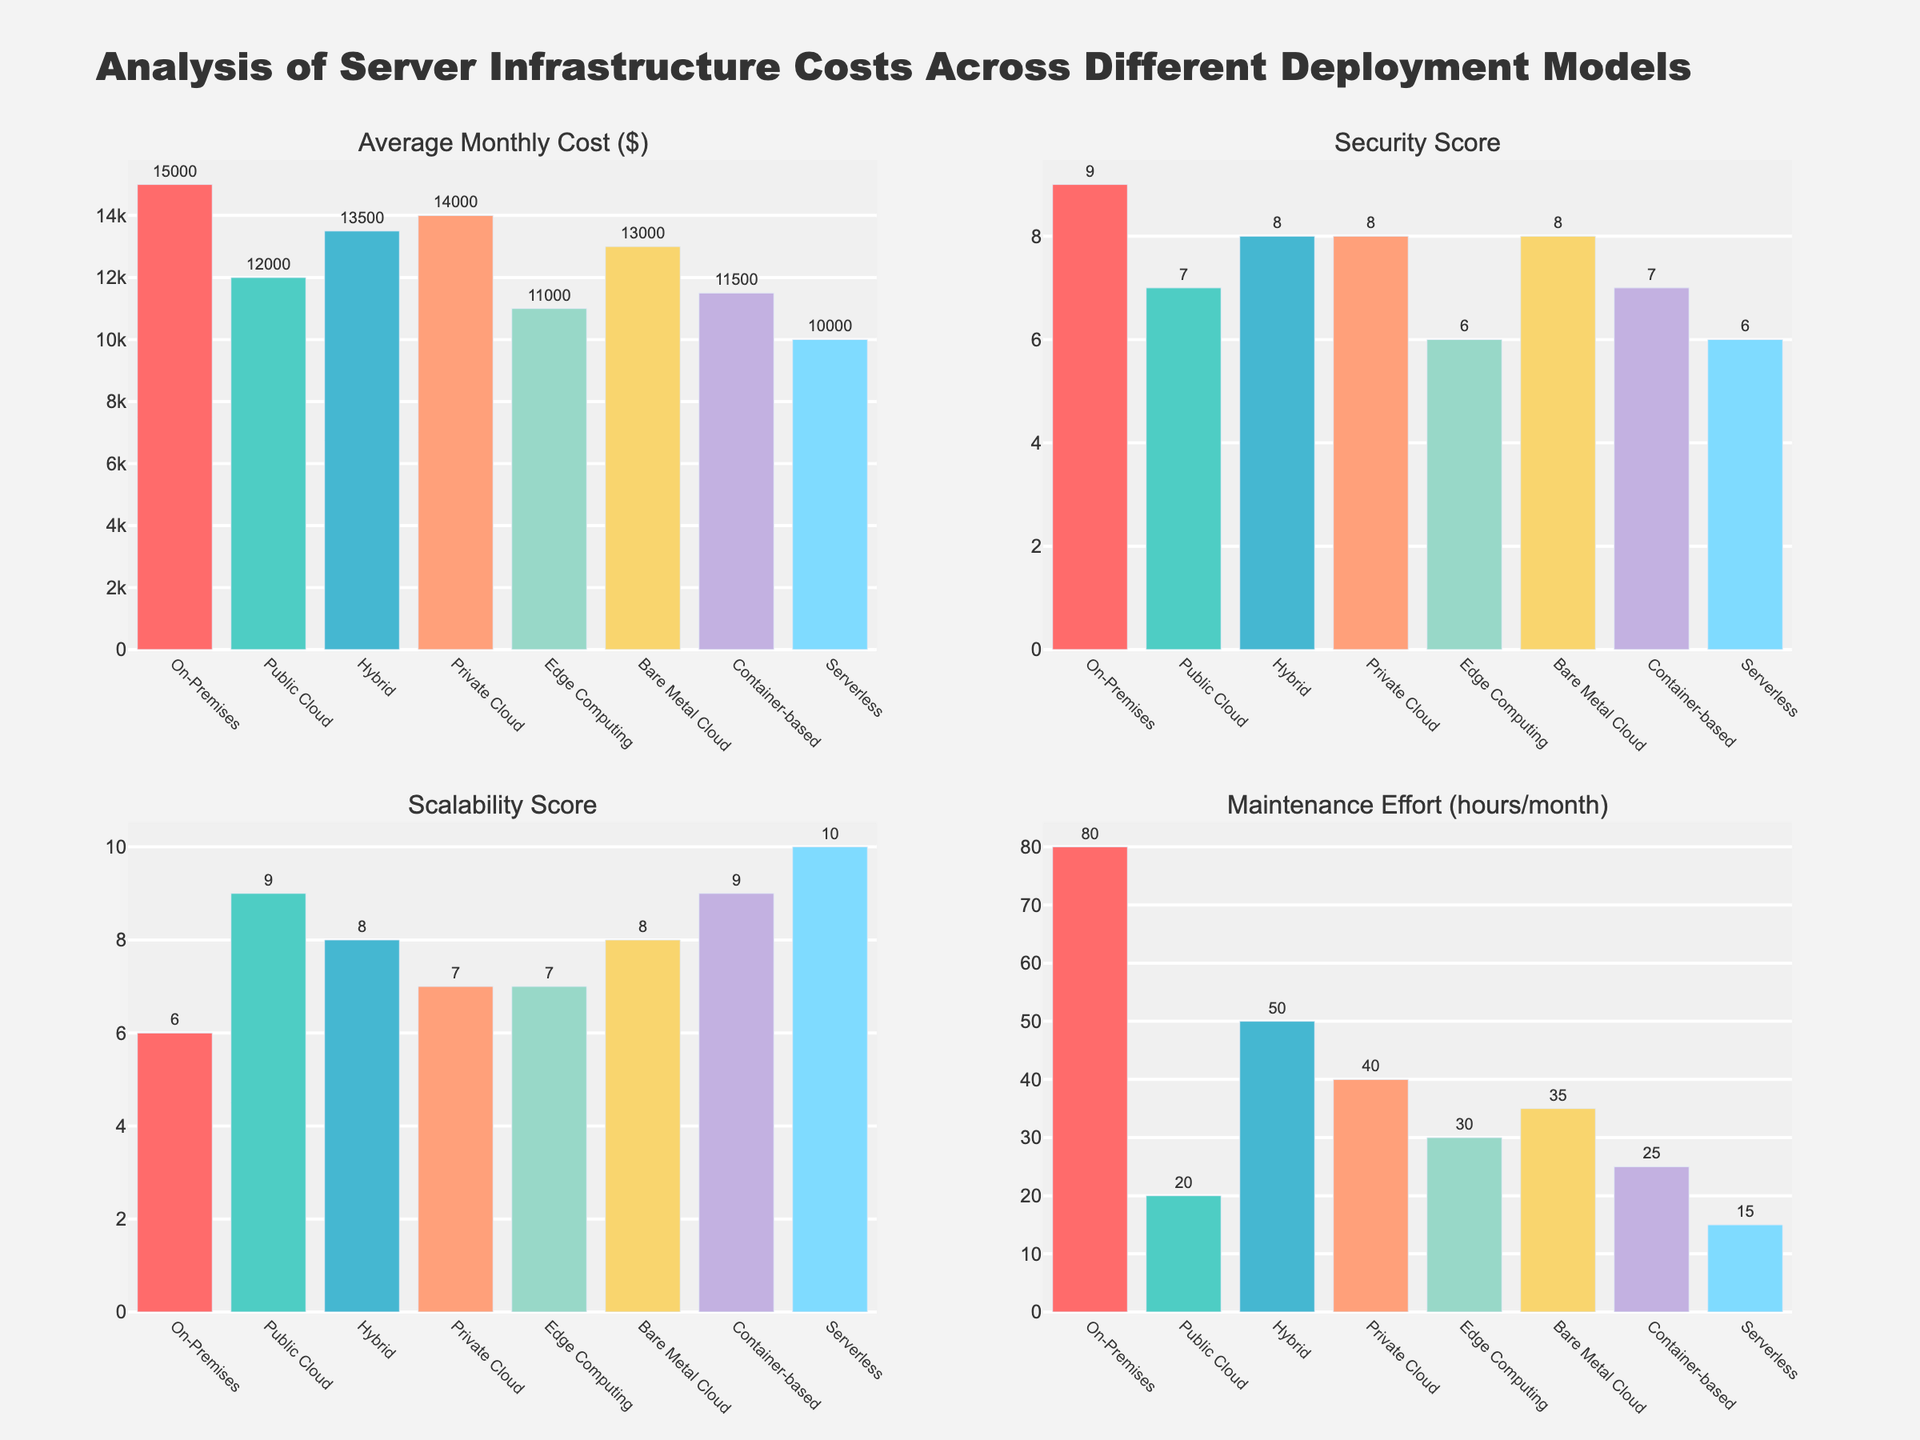What's the deployment model with the highest average monthly cost? The figure shows the average monthly cost for each deployment model in one of the subplots. By comparing the heights of the bars, it is clear that the On-Premises model has the highest average monthly cost.
Answer: On-Premises Which deployment model has the lowest maintenance effort? The subplot showing maintenance effort hours per month allows us to visually compare the heights of the bars. The Serverless model has the lowest maintenance effort according to this bar chart.
Answer: Serverless What's the difference in average monthly cost between the On-Premises and Public Cloud models? The subplot for average monthly cost indicates that the On-Premises model costs $15,000 while the Public Cloud costs $12,000. The difference is calculated as $15,000 - $12,000.
Answer: $3,000 Which deployment models have a scalability score of 9? Observing the subplot for scalability scores, the bars representing Public Cloud and Container-based models both reach the mark of 9.
Answer: Public Cloud, Container-based Rank the deployment models based on their security score from highest to lowest. The subplot for security scores allows us to rank the models by comparing the heights of the bars. They are ranked as follows: On-Premises (9), Hybrid, Private Cloud, Bare Metal Cloud (all 8), Public Cloud, Container-based (both 7), Edge Computing, Serverless (both 6).
Answer: On-Premises, Hybrid, Private Cloud, Bare Metal Cloud, Public Cloud, Container-based, Edge Computing, Serverless If I want a deployment model with a balance of low cost and high scalability, which ones should I consider? From the respective subplots, it is clear Public Cloud and Container-based models both have high scalability scores of 9. However, Public Cloud has a lower average monthly cost ($12,000) compared to Container-based ($11,500). Therefore, both should be considered, with a slight preference for Container-based due to its slightly lower cost.
Answer: Public Cloud, Container-based Between the Private Cloud and Hybrid models, which one has a higher maintenance effort, and by how much? The subplot for maintenance effort shows Private Cloud has 40 hours/month and Hybrid has 50 hours/month, meaning Hybrid has 10 additional maintenance hours per month.
Answer: Hybrid, 10 hours Which deployment model stands out for having both low monthly costs and low maintenance effort? Observing the subplots for average monthly cost and maintenance effort, the Serverless model has the lowest monthly cost ($10,000) and lowest maintenance effort (15 hours/month).
Answer: Serverless What's the average scalability score of all deployment models? Adding up all the scalability scores: 6 (On-Premises) + 9 (Public Cloud) + 8 (Hybrid) + 7 (Private Cloud) + 7 (Edge Computing) + 8 (Bare Metal Cloud) + 9 (Container-based) + 10 (Serverless) = 64. Given there are 8 models, the average is 64/8.
Answer: 8 Compare the security score and maintenance effort of Container-based and Serverless models. Which model is more secure and requires less maintenance effort? The subplot for security scores shows that both Container-based and Serverless have the same security score of 7. However, the subplot for maintenance effort indicates that Serverless requires less maintenance (15 hours) compared to Container-based (25 hours), making Serverless the less maintenance-intensive model.
Answer: Same security, Serverless less maintenance 